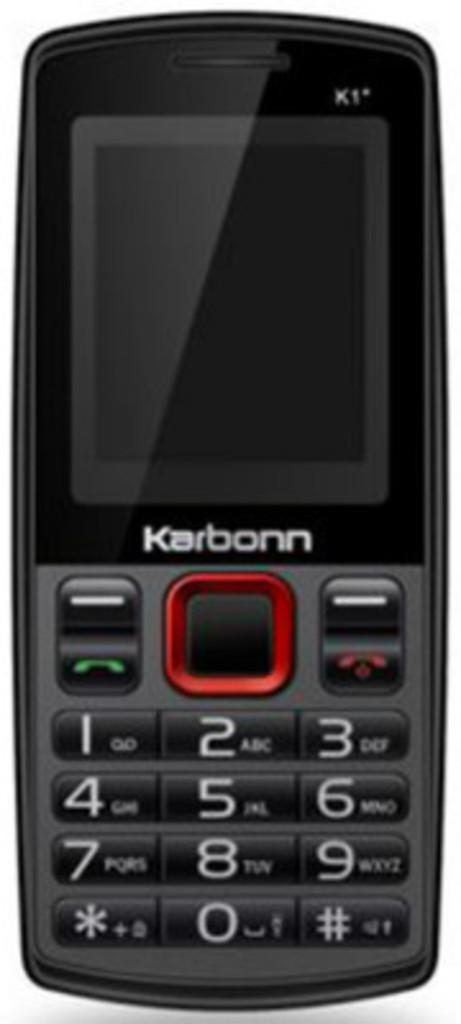<image>
Share a concise interpretation of the image provided. A small gray cellphone has the name Karbonn below its screen. 